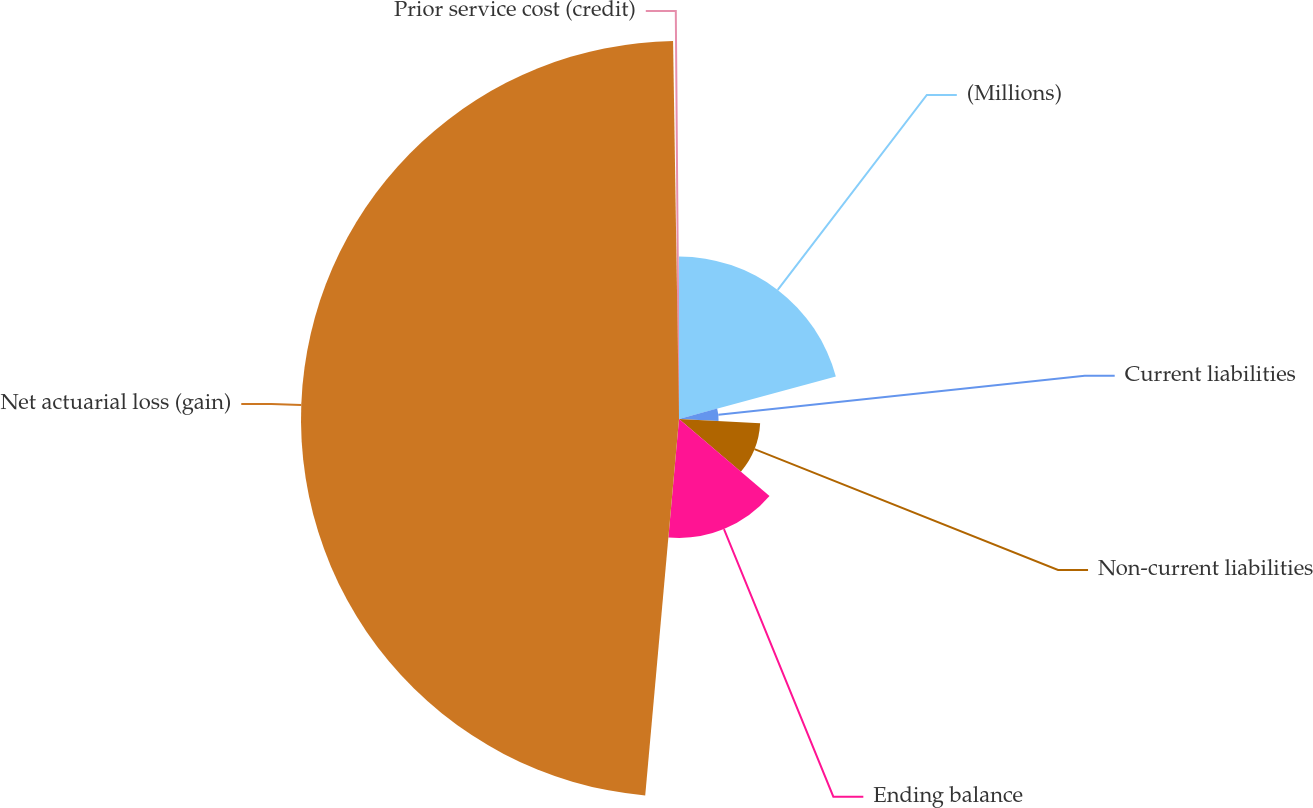Convert chart. <chart><loc_0><loc_0><loc_500><loc_500><pie_chart><fcel>(Millions)<fcel>Current liabilities<fcel>Non-current liabilities<fcel>Ending balance<fcel>Net actuarial loss (gain)<fcel>Prior service cost (credit)<nl><fcel>20.78%<fcel>5.06%<fcel>10.39%<fcel>15.2%<fcel>48.33%<fcel>0.25%<nl></chart> 